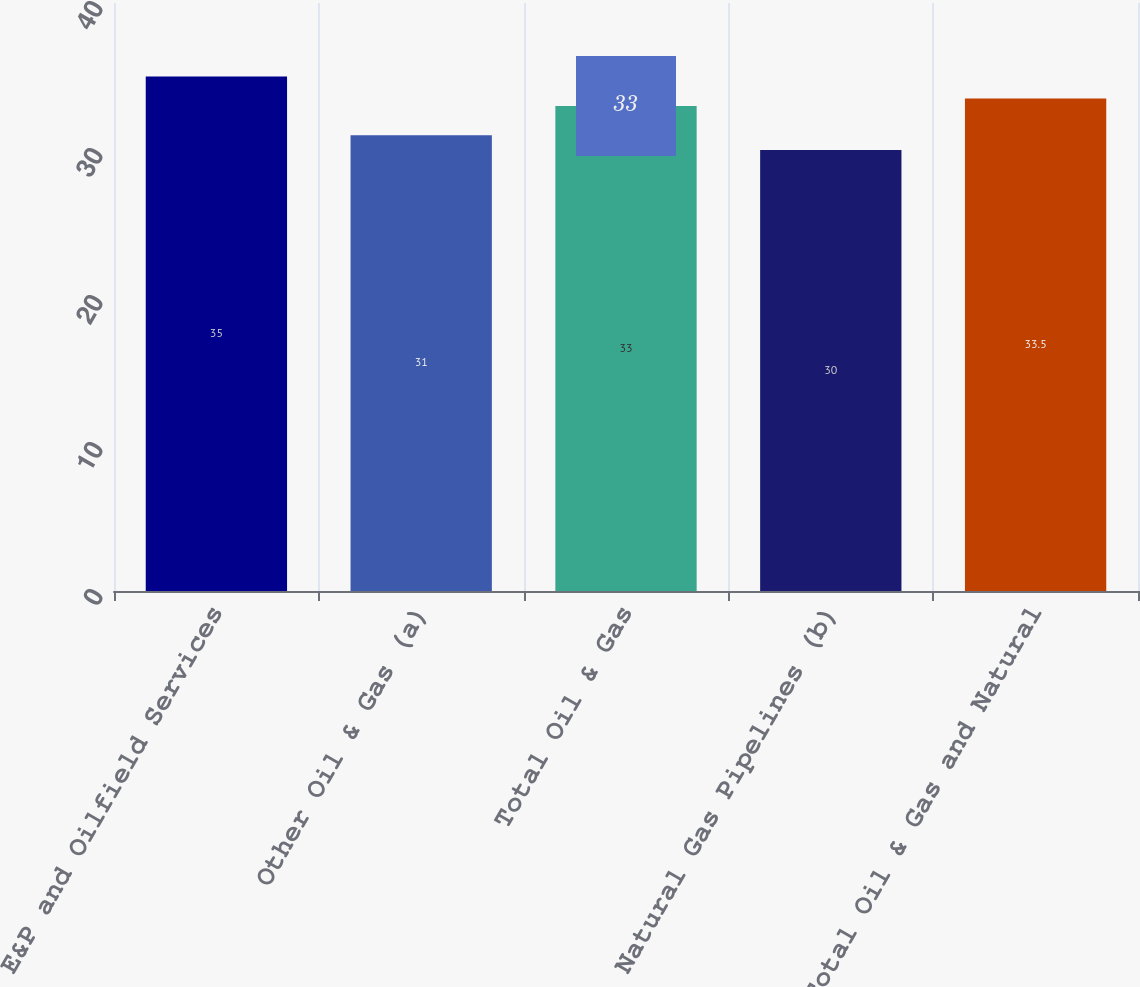Convert chart to OTSL. <chart><loc_0><loc_0><loc_500><loc_500><bar_chart><fcel>E&P and Oilfield Services<fcel>Other Oil & Gas (a)<fcel>Total Oil & Gas<fcel>Natural Gas Pipelines (b)<fcel>Total Oil & Gas and Natural<nl><fcel>35<fcel>31<fcel>33<fcel>30<fcel>33.5<nl></chart> 